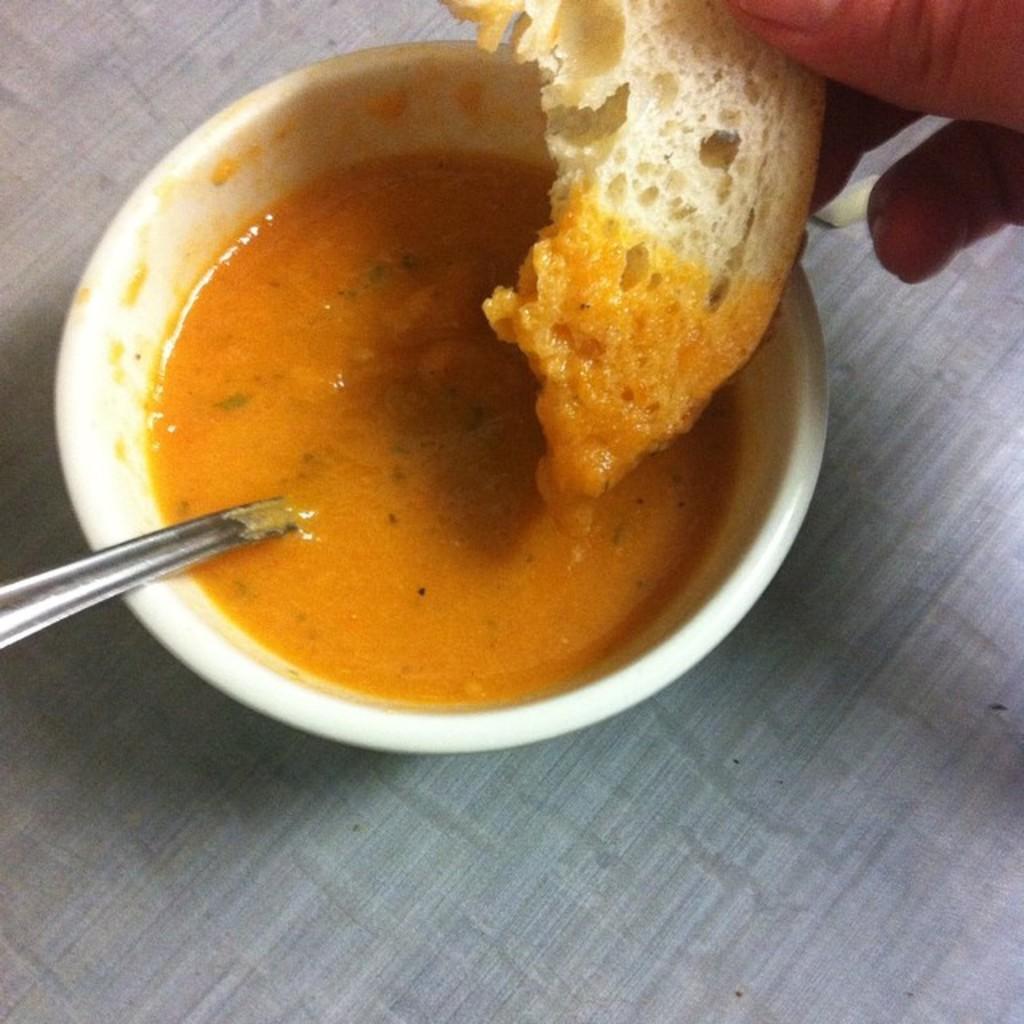Describe this image in one or two sentences. This image consist of food and there is a spoon in the bowl. On the right side there is the hand which is visible. 